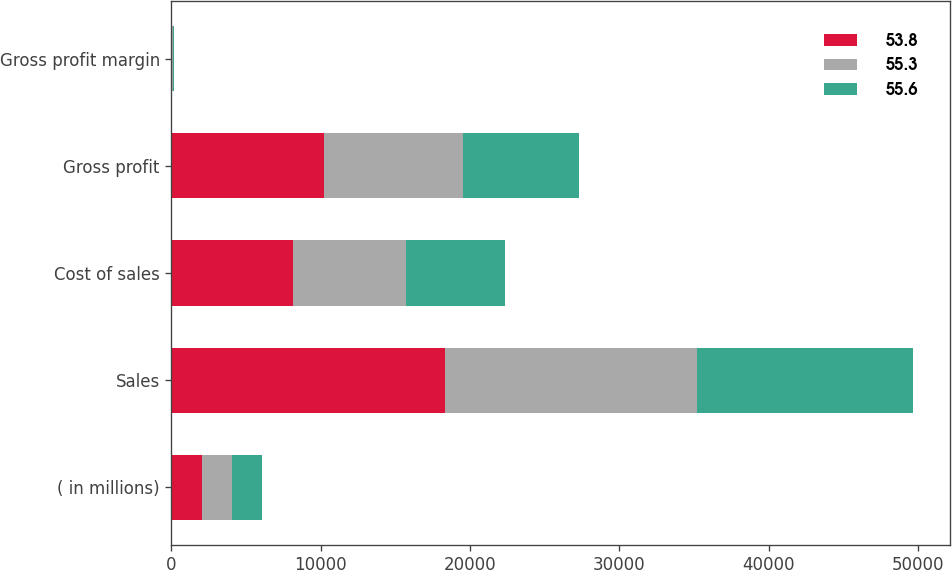Convert chart. <chart><loc_0><loc_0><loc_500><loc_500><stacked_bar_chart><ecel><fcel>( in millions)<fcel>Sales<fcel>Cost of sales<fcel>Gross profit<fcel>Gross profit margin<nl><fcel>53.8<fcel>2017<fcel>18329.7<fcel>8137.2<fcel>10192.5<fcel>55.6<nl><fcel>55.3<fcel>2016<fcel>16882.4<fcel>7547.8<fcel>9334.6<fcel>55.3<nl><fcel>55.6<fcel>2015<fcel>14433.7<fcel>6662.6<fcel>7771.1<fcel>53.8<nl></chart> 